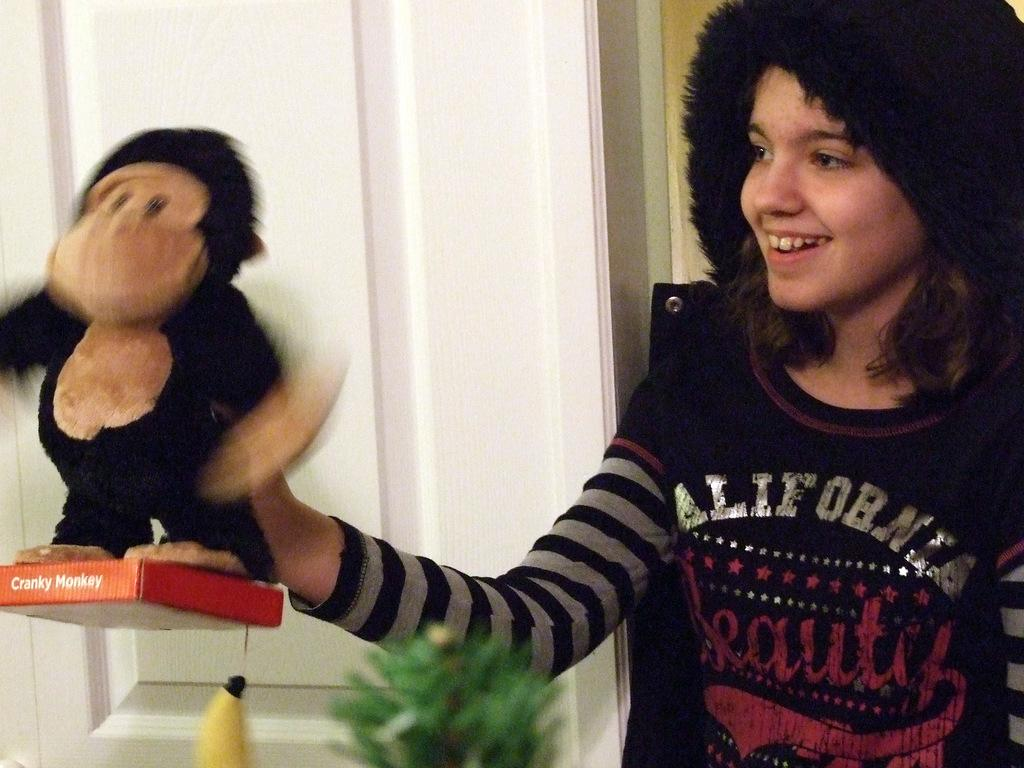Who is in the image? There is a person in the image. What is the person doing? The person is smiling. What is the person wearing on their head? The person is wearing a cap. What is the person holding? The person is holding a toy. What can be seen in the background of the image? There is a wall, a plant, a box, and an object in the background of the image. What type of friction is present between the person and the toy in the image? There is no indication of friction between the person and the toy in the image. The person is simply holding the toy, and there is no information about any resistance or force between them. 